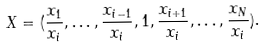Convert formula to latex. <formula><loc_0><loc_0><loc_500><loc_500>X = ( \frac { x _ { 1 } } { x _ { i } } , \dots , \frac { x _ { i - 1 } } { x _ { i } } , 1 , \frac { x _ { i + 1 } } { x _ { i } } , \dots , \frac { x _ { N } } { x _ { i } } ) .</formula> 